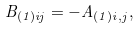Convert formula to latex. <formula><loc_0><loc_0><loc_500><loc_500>B _ { ( 1 ) i j } = - A _ { ( 1 ) i , j } ,</formula> 